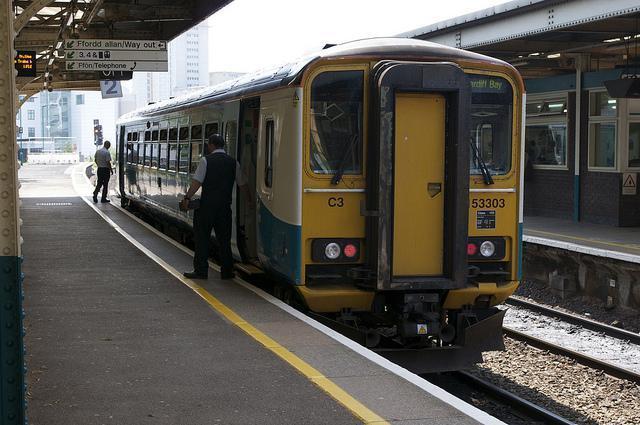How many different types of dogs are there?
Give a very brief answer. 0. 